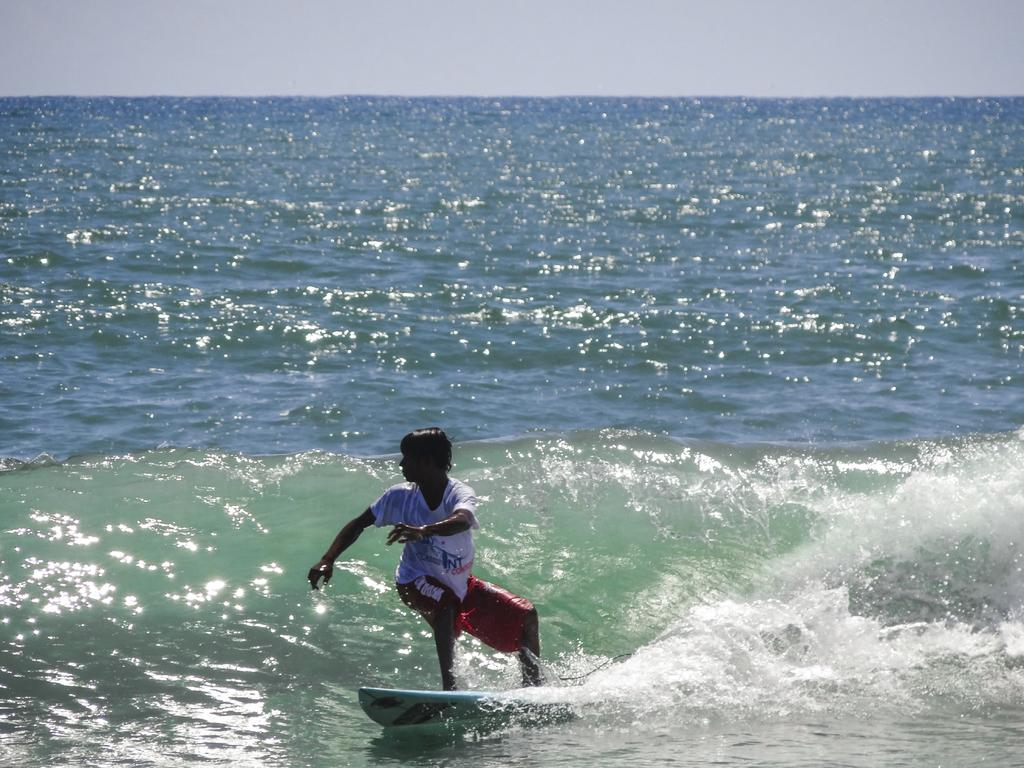What is the man in the image doing? The man is surfing on a surfboard. Where is the man located in the image? The man is on the surface of the water. What else can be seen in the image besides the man? There is water visible in the image. What is visible in the background of the image? The sky is visible in the background of the image. What type of scent is the man's aunt wearing in the image? There is no mention of an aunt or any scent in the image; it features a man surfing on a surfboard. 